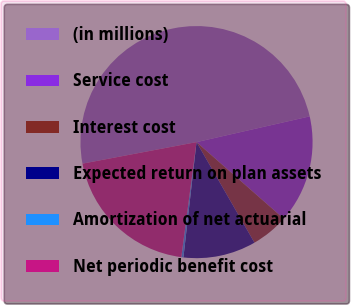Convert chart. <chart><loc_0><loc_0><loc_500><loc_500><pie_chart><fcel>(in millions)<fcel>Service cost<fcel>Interest cost<fcel>Expected return on plan assets<fcel>Amortization of net actuarial<fcel>Net periodic benefit cost<nl><fcel>49.41%<fcel>15.03%<fcel>5.21%<fcel>10.12%<fcel>0.29%<fcel>19.94%<nl></chart> 